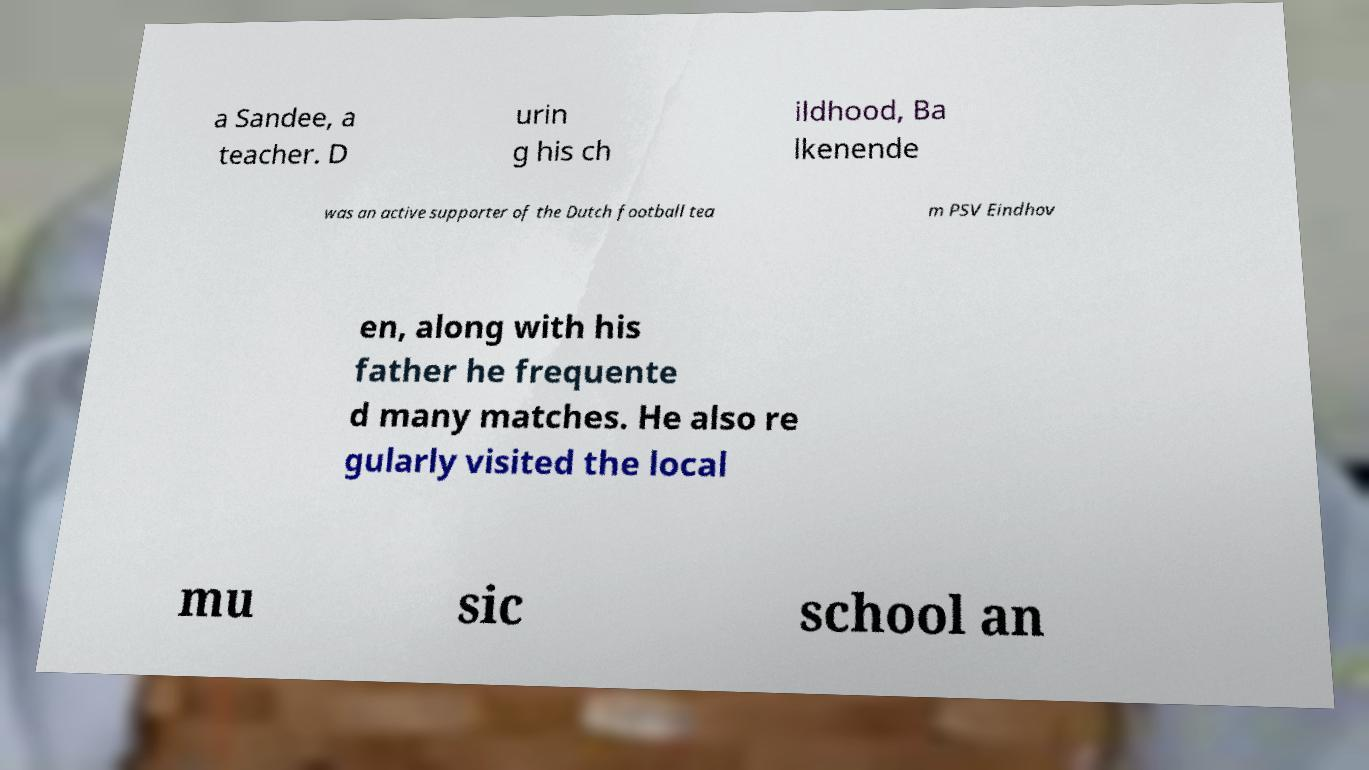There's text embedded in this image that I need extracted. Can you transcribe it verbatim? a Sandee, a teacher. D urin g his ch ildhood, Ba lkenende was an active supporter of the Dutch football tea m PSV Eindhov en, along with his father he frequente d many matches. He also re gularly visited the local mu sic school an 